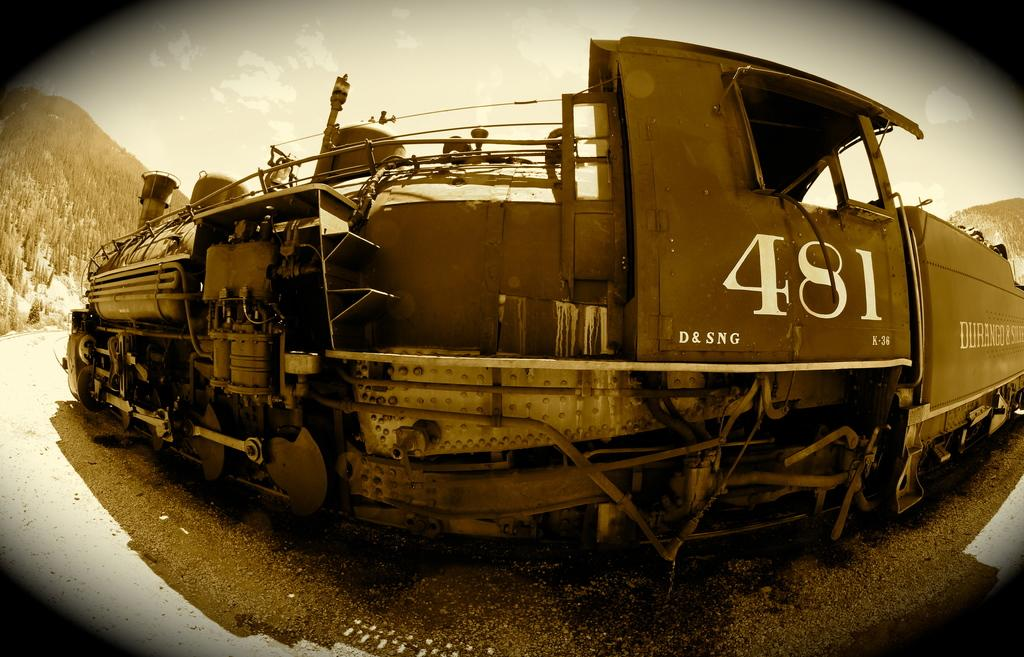Provide a one-sentence caption for the provided image. The numbers 481 on the side of the train. 